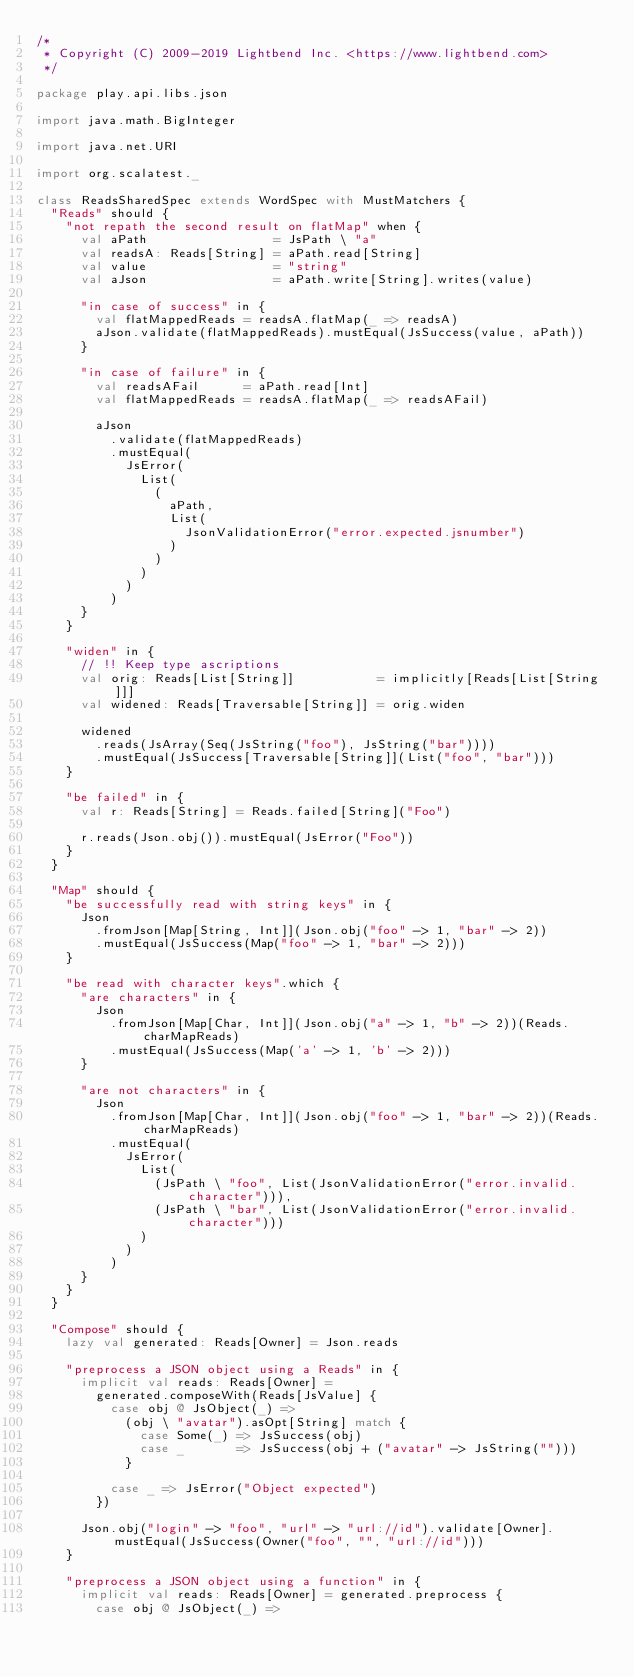Convert code to text. <code><loc_0><loc_0><loc_500><loc_500><_Scala_>/*
 * Copyright (C) 2009-2019 Lightbend Inc. <https://www.lightbend.com>
 */

package play.api.libs.json

import java.math.BigInteger

import java.net.URI

import org.scalatest._

class ReadsSharedSpec extends WordSpec with MustMatchers {
  "Reads" should {
    "not repath the second result on flatMap" when {
      val aPath                 = JsPath \ "a"
      val readsA: Reads[String] = aPath.read[String]
      val value                 = "string"
      val aJson                 = aPath.write[String].writes(value)

      "in case of success" in {
        val flatMappedReads = readsA.flatMap(_ => readsA)
        aJson.validate(flatMappedReads).mustEqual(JsSuccess(value, aPath))
      }

      "in case of failure" in {
        val readsAFail      = aPath.read[Int]
        val flatMappedReads = readsA.flatMap(_ => readsAFail)

        aJson
          .validate(flatMappedReads)
          .mustEqual(
            JsError(
              List(
                (
                  aPath,
                  List(
                    JsonValidationError("error.expected.jsnumber")
                  )
                )
              )
            )
          )
      }
    }

    "widen" in {
      // !! Keep type ascriptions
      val orig: Reads[List[String]]           = implicitly[Reads[List[String]]]
      val widened: Reads[Traversable[String]] = orig.widen

      widened
        .reads(JsArray(Seq(JsString("foo"), JsString("bar"))))
        .mustEqual(JsSuccess[Traversable[String]](List("foo", "bar")))
    }

    "be failed" in {
      val r: Reads[String] = Reads.failed[String]("Foo")

      r.reads(Json.obj()).mustEqual(JsError("Foo"))
    }
  }

  "Map" should {
    "be successfully read with string keys" in {
      Json
        .fromJson[Map[String, Int]](Json.obj("foo" -> 1, "bar" -> 2))
        .mustEqual(JsSuccess(Map("foo" -> 1, "bar" -> 2)))
    }

    "be read with character keys".which {
      "are characters" in {
        Json
          .fromJson[Map[Char, Int]](Json.obj("a" -> 1, "b" -> 2))(Reads.charMapReads)
          .mustEqual(JsSuccess(Map('a' -> 1, 'b' -> 2)))
      }

      "are not characters" in {
        Json
          .fromJson[Map[Char, Int]](Json.obj("foo" -> 1, "bar" -> 2))(Reads.charMapReads)
          .mustEqual(
            JsError(
              List(
                (JsPath \ "foo", List(JsonValidationError("error.invalid.character"))),
                (JsPath \ "bar", List(JsonValidationError("error.invalid.character")))
              )
            )
          )
      }
    }
  }

  "Compose" should {
    lazy val generated: Reads[Owner] = Json.reads

    "preprocess a JSON object using a Reads" in {
      implicit val reads: Reads[Owner] =
        generated.composeWith(Reads[JsValue] {
          case obj @ JsObject(_) =>
            (obj \ "avatar").asOpt[String] match {
              case Some(_) => JsSuccess(obj)
              case _       => JsSuccess(obj + ("avatar" -> JsString("")))
            }

          case _ => JsError("Object expected")
        })

      Json.obj("login" -> "foo", "url" -> "url://id").validate[Owner].mustEqual(JsSuccess(Owner("foo", "", "url://id")))
    }

    "preprocess a JSON object using a function" in {
      implicit val reads: Reads[Owner] = generated.preprocess {
        case obj @ JsObject(_) =></code> 